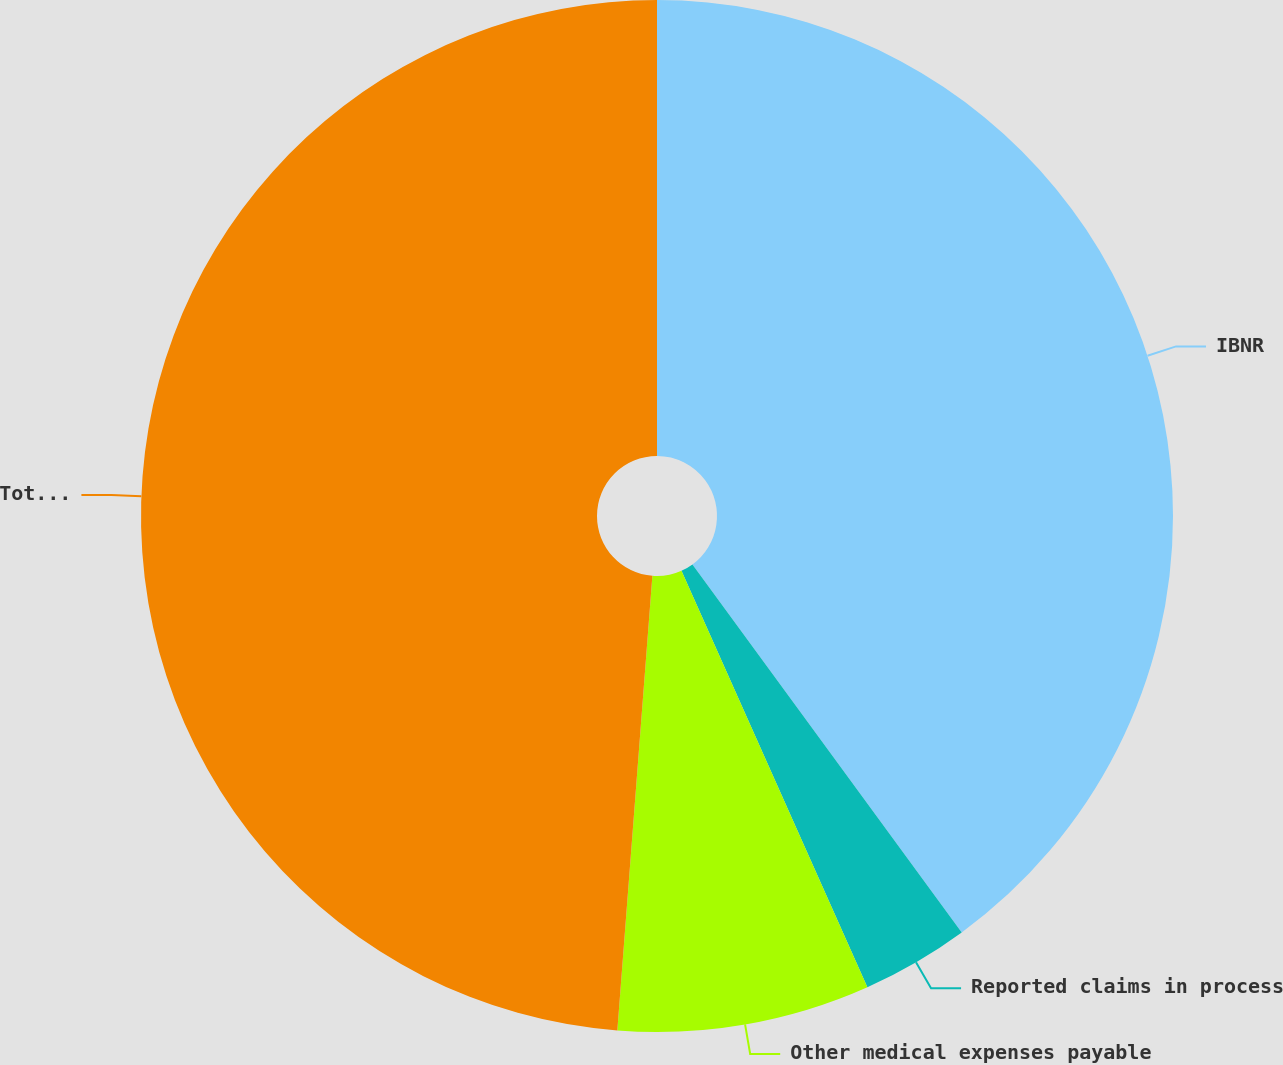Convert chart. <chart><loc_0><loc_0><loc_500><loc_500><pie_chart><fcel>IBNR<fcel>Reported claims in process<fcel>Other medical expenses payable<fcel>Total medical and other<nl><fcel>39.95%<fcel>3.37%<fcel>7.91%<fcel>48.78%<nl></chart> 